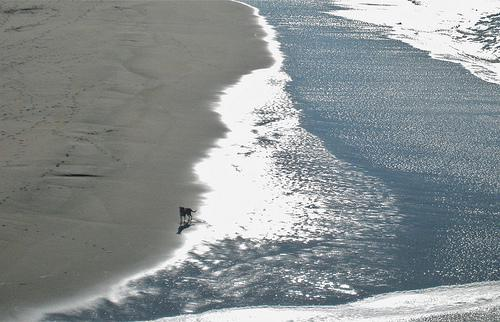Question: where is the dog standing?
Choices:
A. In the grass.
B. At the shoreline.
C. At his bowl.
D. At the road.
Answer with the letter. Answer: B Question: what is in the picture?
Choices:
A. A cat.
B. A horse.
C. A dog.
D. A elephant.
Answer with the letter. Answer: C Question: where is this picture taken?
Choices:
A. The park.
B. The cafe.
C. The movie theather.
D. The beach.
Answer with the letter. Answer: D Question: what color is the sand?
Choices:
A. Blue.
B. Brown.
C. White.
D. Grey.
Answer with the letter. Answer: D 